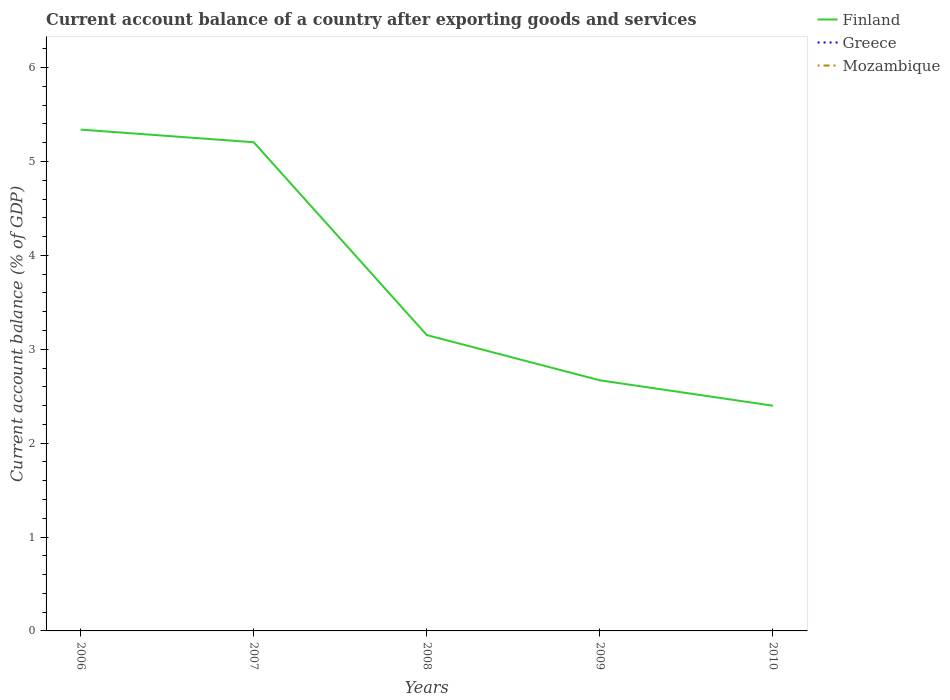Does the line corresponding to Finland intersect with the line corresponding to Mozambique?
Provide a succinct answer. No. Is the number of lines equal to the number of legend labels?
Provide a short and direct response. No. Across all years, what is the maximum account balance in Greece?
Your response must be concise. 0. What is the total account balance in Finland in the graph?
Offer a very short reply. 2.54. What is the difference between the highest and the lowest account balance in Finland?
Your response must be concise. 2. Is the account balance in Finland strictly greater than the account balance in Mozambique over the years?
Provide a succinct answer. No. Are the values on the major ticks of Y-axis written in scientific E-notation?
Make the answer very short. No. Does the graph contain grids?
Ensure brevity in your answer.  No. Where does the legend appear in the graph?
Give a very brief answer. Top right. How many legend labels are there?
Provide a short and direct response. 3. What is the title of the graph?
Provide a short and direct response. Current account balance of a country after exporting goods and services. Does "Central Europe" appear as one of the legend labels in the graph?
Give a very brief answer. No. What is the label or title of the Y-axis?
Your answer should be very brief. Current account balance (% of GDP). What is the Current account balance (% of GDP) in Finland in 2006?
Your response must be concise. 5.34. What is the Current account balance (% of GDP) in Mozambique in 2006?
Offer a terse response. 0. What is the Current account balance (% of GDP) in Finland in 2007?
Offer a terse response. 5.2. What is the Current account balance (% of GDP) in Greece in 2007?
Offer a very short reply. 0. What is the Current account balance (% of GDP) in Finland in 2008?
Ensure brevity in your answer.  3.15. What is the Current account balance (% of GDP) of Greece in 2008?
Your response must be concise. 0. What is the Current account balance (% of GDP) in Mozambique in 2008?
Your answer should be compact. 0. What is the Current account balance (% of GDP) in Finland in 2009?
Your answer should be compact. 2.67. What is the Current account balance (% of GDP) of Greece in 2009?
Provide a short and direct response. 0. What is the Current account balance (% of GDP) of Mozambique in 2009?
Your response must be concise. 0. What is the Current account balance (% of GDP) in Finland in 2010?
Your answer should be compact. 2.4. Across all years, what is the maximum Current account balance (% of GDP) of Finland?
Ensure brevity in your answer.  5.34. Across all years, what is the minimum Current account balance (% of GDP) of Finland?
Ensure brevity in your answer.  2.4. What is the total Current account balance (% of GDP) in Finland in the graph?
Ensure brevity in your answer.  18.76. What is the total Current account balance (% of GDP) in Greece in the graph?
Your response must be concise. 0. What is the difference between the Current account balance (% of GDP) in Finland in 2006 and that in 2007?
Your response must be concise. 0.13. What is the difference between the Current account balance (% of GDP) of Finland in 2006 and that in 2008?
Make the answer very short. 2.19. What is the difference between the Current account balance (% of GDP) in Finland in 2006 and that in 2009?
Keep it short and to the point. 2.67. What is the difference between the Current account balance (% of GDP) of Finland in 2006 and that in 2010?
Your response must be concise. 2.94. What is the difference between the Current account balance (% of GDP) in Finland in 2007 and that in 2008?
Give a very brief answer. 2.05. What is the difference between the Current account balance (% of GDP) in Finland in 2007 and that in 2009?
Your answer should be very brief. 2.54. What is the difference between the Current account balance (% of GDP) in Finland in 2007 and that in 2010?
Your answer should be very brief. 2.81. What is the difference between the Current account balance (% of GDP) of Finland in 2008 and that in 2009?
Ensure brevity in your answer.  0.48. What is the difference between the Current account balance (% of GDP) in Finland in 2008 and that in 2010?
Your answer should be very brief. 0.75. What is the difference between the Current account balance (% of GDP) in Finland in 2009 and that in 2010?
Ensure brevity in your answer.  0.27. What is the average Current account balance (% of GDP) in Finland per year?
Offer a very short reply. 3.75. What is the average Current account balance (% of GDP) in Mozambique per year?
Offer a very short reply. 0. What is the ratio of the Current account balance (% of GDP) in Finland in 2006 to that in 2007?
Provide a succinct answer. 1.03. What is the ratio of the Current account balance (% of GDP) in Finland in 2006 to that in 2008?
Offer a very short reply. 1.69. What is the ratio of the Current account balance (% of GDP) in Finland in 2006 to that in 2009?
Your response must be concise. 2. What is the ratio of the Current account balance (% of GDP) of Finland in 2006 to that in 2010?
Ensure brevity in your answer.  2.23. What is the ratio of the Current account balance (% of GDP) in Finland in 2007 to that in 2008?
Keep it short and to the point. 1.65. What is the ratio of the Current account balance (% of GDP) in Finland in 2007 to that in 2009?
Give a very brief answer. 1.95. What is the ratio of the Current account balance (% of GDP) of Finland in 2007 to that in 2010?
Your answer should be very brief. 2.17. What is the ratio of the Current account balance (% of GDP) in Finland in 2008 to that in 2009?
Offer a terse response. 1.18. What is the ratio of the Current account balance (% of GDP) of Finland in 2008 to that in 2010?
Keep it short and to the point. 1.31. What is the ratio of the Current account balance (% of GDP) of Finland in 2009 to that in 2010?
Keep it short and to the point. 1.11. What is the difference between the highest and the second highest Current account balance (% of GDP) of Finland?
Your response must be concise. 0.13. What is the difference between the highest and the lowest Current account balance (% of GDP) in Finland?
Offer a very short reply. 2.94. 